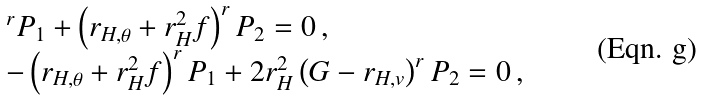Convert formula to latex. <formula><loc_0><loc_0><loc_500><loc_500>\begin{array} { l l } & ^ { r } P _ { 1 } + \left ( r _ { H , \theta } + r _ { H } ^ { 2 } f \right ) ^ { r } P _ { 2 } = 0 \, , \\ & - \left ( r _ { H , \theta } + r _ { H } ^ { 2 } f \right ) ^ { r } P _ { 1 } + 2 r _ { H } ^ { 2 } \left ( G - r _ { H , v } \right ) ^ { r } P _ { 2 } = 0 \, , \end{array}</formula> 